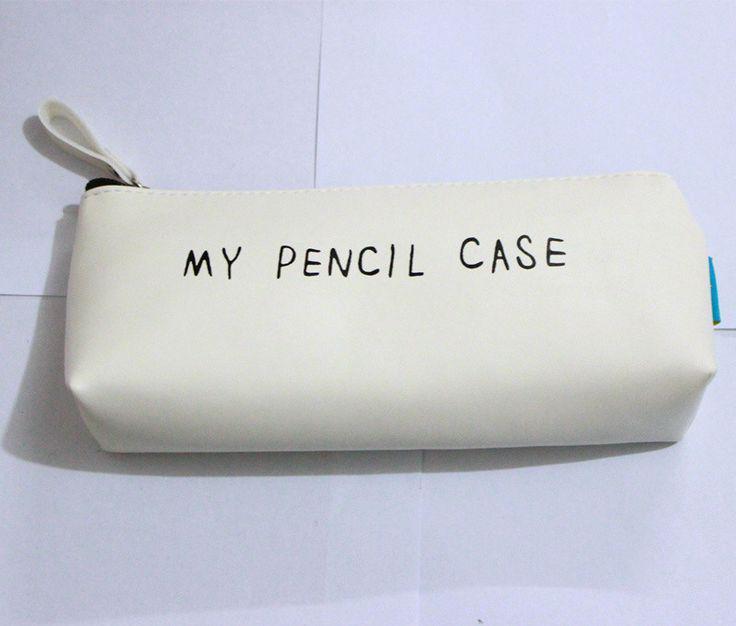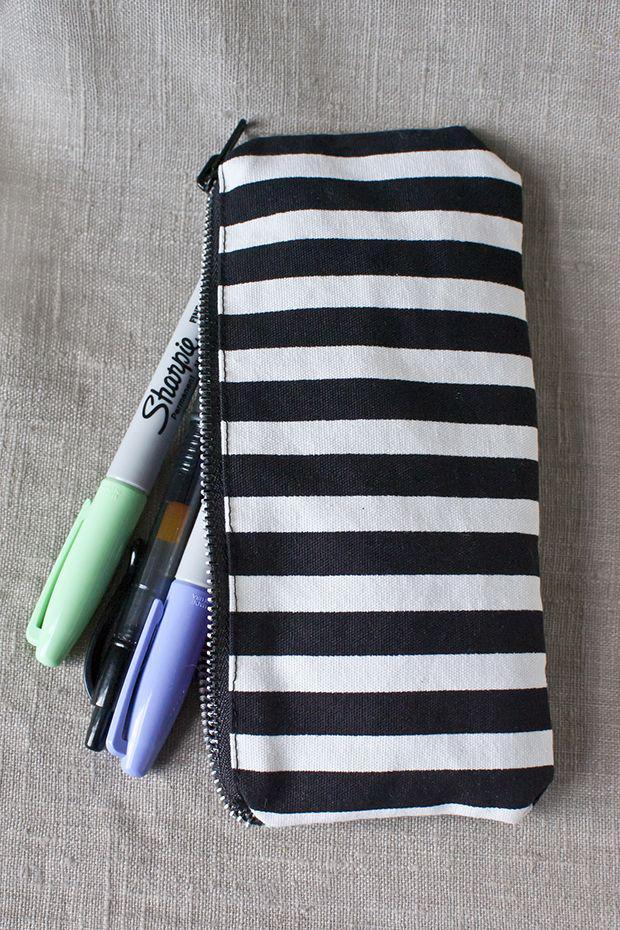The first image is the image on the left, the second image is the image on the right. Assess this claim about the two images: "There are exactly two pencil bags, and there are pencils and/or pens sticking out of the left one.". Correct or not? Answer yes or no. No. The first image is the image on the left, the second image is the image on the right. Given the left and right images, does the statement "One image shows a black-and-white pencil case made of patterned fabric, and the other shows a case with a phrase across the front." hold true? Answer yes or no. Yes. 